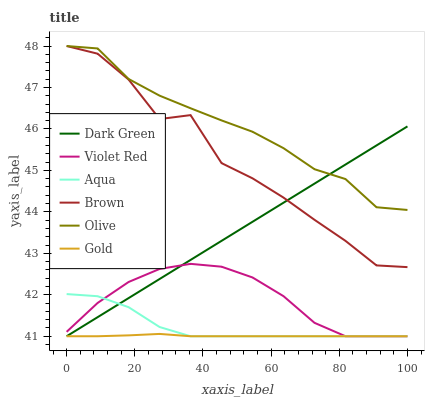Does Violet Red have the minimum area under the curve?
Answer yes or no. No. Does Violet Red have the maximum area under the curve?
Answer yes or no. No. Is Violet Red the smoothest?
Answer yes or no. No. Is Violet Red the roughest?
Answer yes or no. No. Does Olive have the lowest value?
Answer yes or no. No. Does Violet Red have the highest value?
Answer yes or no. No. Is Gold less than Olive?
Answer yes or no. Yes. Is Olive greater than Violet Red?
Answer yes or no. Yes. Does Gold intersect Olive?
Answer yes or no. No. 